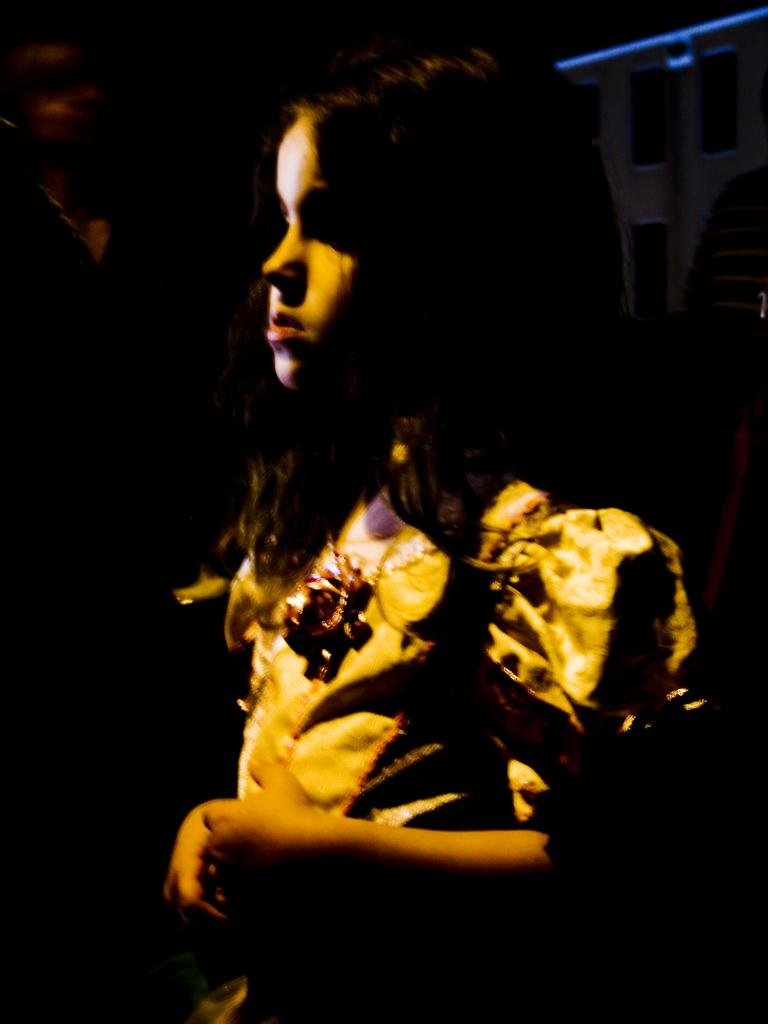Who is the main subject in the picture? There is a little girl in the picture. What is the girl doing in the image? The girl is standing. Where is the girl looking in the image? The girl is looking at somewhere. What can be observed about the background of the image? The background of the image is dark. How many bricks are visible in the image? There are no bricks present in the image; it features a little girl standing and looking at somewhere. What day of the week is depicted in the image? The image does not depict a specific day of the week; it only shows a little girl standing and looking at somewhere. 